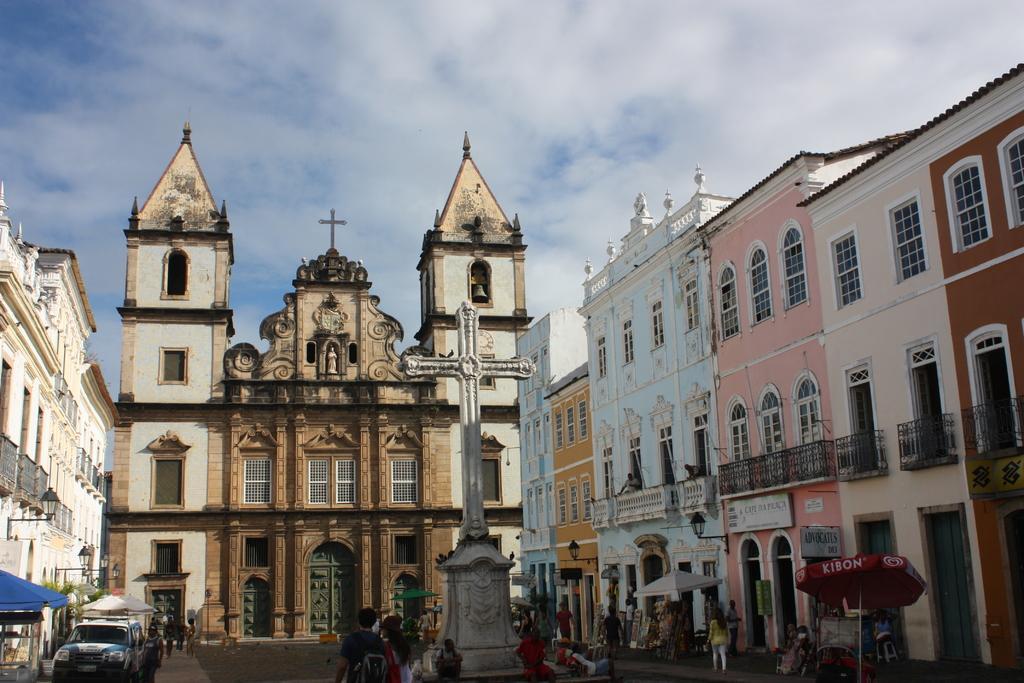Can you describe this image briefly? In this image I can see few buildings, the ground, few vehicles on the ground, few persons standing, few umbrellas which are blue, red and white in color, a white colored pole and in the background I can see the sky. 